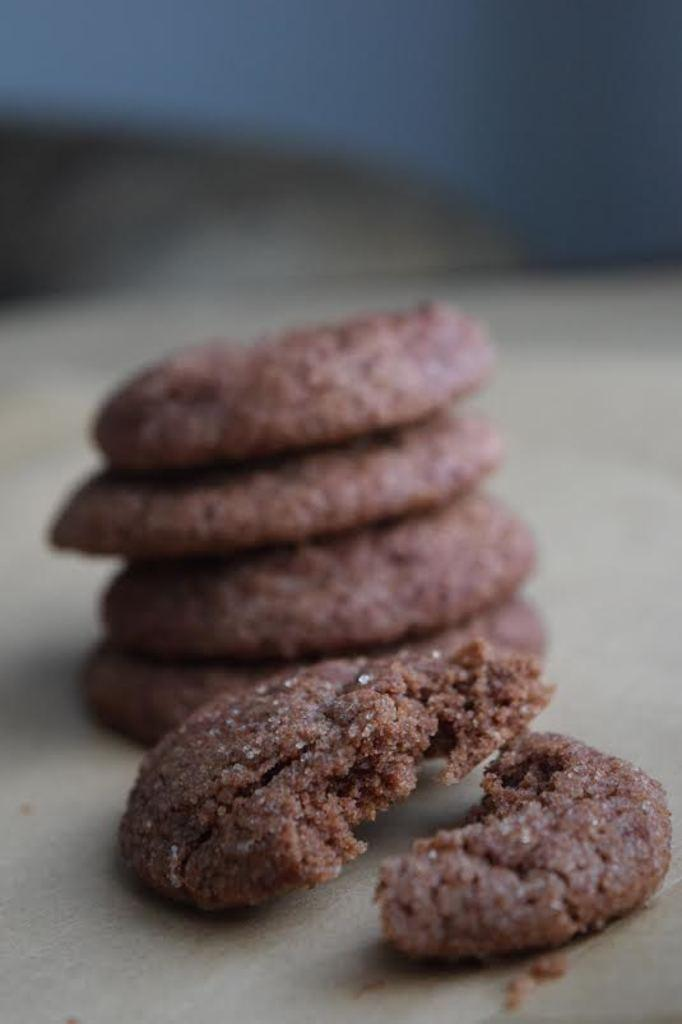What types of food items are visible in the image? There are food items in the image, but their specific types cannot be determined from the provided facts. On what surface are the food items placed? The food items are on a white surface. What can be observed about the background of the image? The background of the image is blurred. Can you tell me the angle at which the ladybug is flying in the image? There is no ladybug present in the image, so it is not possible to determine the angle at which it might be flying. 